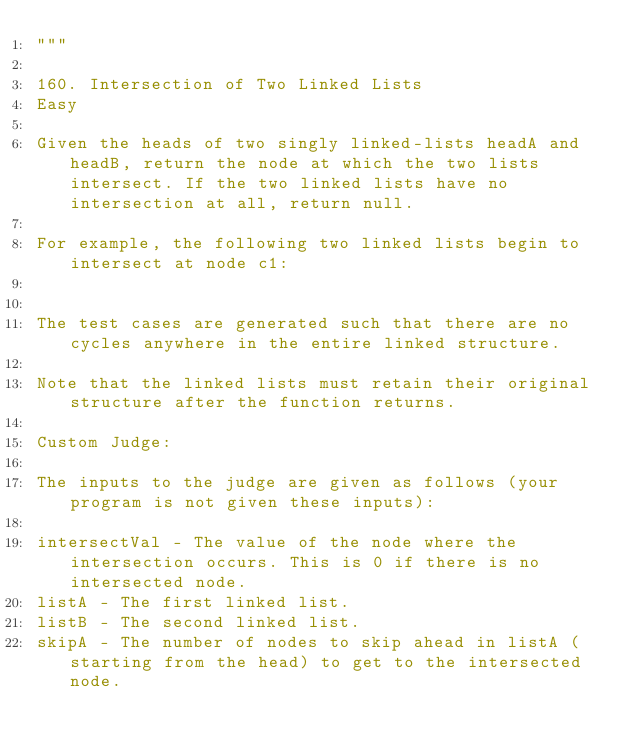Convert code to text. <code><loc_0><loc_0><loc_500><loc_500><_Python_>"""

160. Intersection of Two Linked Lists
Easy

Given the heads of two singly linked-lists headA and headB, return the node at which the two lists intersect. If the two linked lists have no intersection at all, return null.

For example, the following two linked lists begin to intersect at node c1:


The test cases are generated such that there are no cycles anywhere in the entire linked structure.

Note that the linked lists must retain their original structure after the function returns.

Custom Judge:

The inputs to the judge are given as follows (your program is not given these inputs):

intersectVal - The value of the node where the intersection occurs. This is 0 if there is no intersected node.
listA - The first linked list.
listB - The second linked list.
skipA - The number of nodes to skip ahead in listA (starting from the head) to get to the intersected node.</code> 